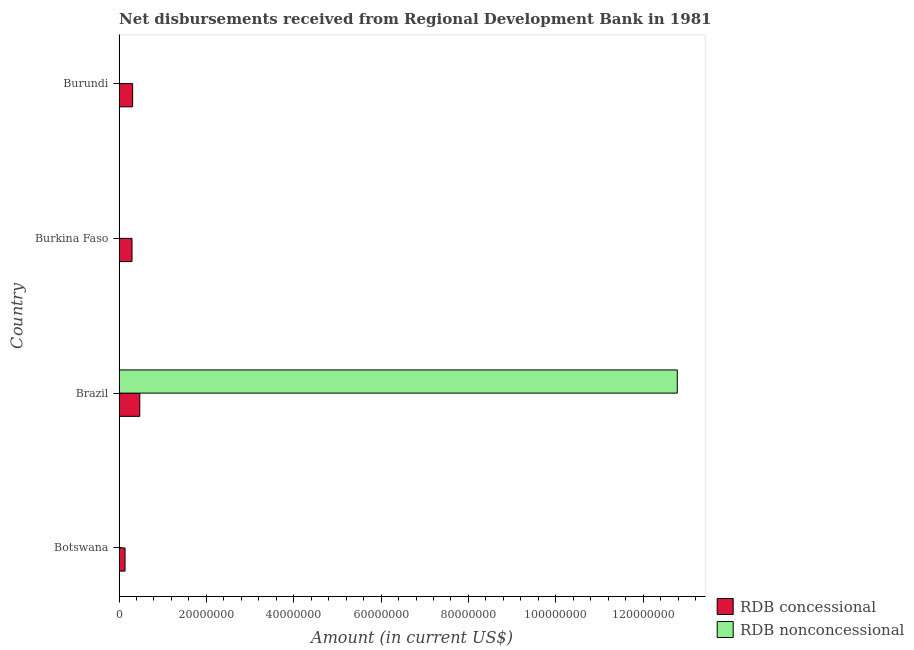How many different coloured bars are there?
Keep it short and to the point. 2. How many bars are there on the 4th tick from the bottom?
Make the answer very short. 1. What is the label of the 3rd group of bars from the top?
Offer a very short reply. Brazil. In how many cases, is the number of bars for a given country not equal to the number of legend labels?
Give a very brief answer. 3. What is the net non concessional disbursements from rdb in Brazil?
Provide a succinct answer. 1.28e+08. Across all countries, what is the maximum net non concessional disbursements from rdb?
Your response must be concise. 1.28e+08. Across all countries, what is the minimum net non concessional disbursements from rdb?
Your answer should be very brief. 0. What is the total net non concessional disbursements from rdb in the graph?
Offer a terse response. 1.28e+08. What is the difference between the net concessional disbursements from rdb in Botswana and that in Burundi?
Keep it short and to the point. -1.74e+06. What is the difference between the net concessional disbursements from rdb in Brazil and the net non concessional disbursements from rdb in Burkina Faso?
Offer a terse response. 4.74e+06. What is the average net concessional disbursements from rdb per country?
Provide a short and direct response. 3.05e+06. What is the difference between the net non concessional disbursements from rdb and net concessional disbursements from rdb in Brazil?
Provide a short and direct response. 1.23e+08. What is the ratio of the net concessional disbursements from rdb in Botswana to that in Burundi?
Your response must be concise. 0.44. What is the difference between the highest and the second highest net concessional disbursements from rdb?
Make the answer very short. 1.63e+06. What is the difference between the highest and the lowest net concessional disbursements from rdb?
Your response must be concise. 3.37e+06. In how many countries, is the net non concessional disbursements from rdb greater than the average net non concessional disbursements from rdb taken over all countries?
Your answer should be very brief. 1. Is the sum of the net concessional disbursements from rdb in Burkina Faso and Burundi greater than the maximum net non concessional disbursements from rdb across all countries?
Provide a succinct answer. No. Are all the bars in the graph horizontal?
Keep it short and to the point. Yes. How many countries are there in the graph?
Your answer should be compact. 4. Where does the legend appear in the graph?
Ensure brevity in your answer.  Bottom right. How many legend labels are there?
Give a very brief answer. 2. What is the title of the graph?
Your answer should be very brief. Net disbursements received from Regional Development Bank in 1981. Does "National Visitors" appear as one of the legend labels in the graph?
Provide a short and direct response. No. What is the label or title of the X-axis?
Provide a succinct answer. Amount (in current US$). What is the Amount (in current US$) in RDB concessional in Botswana?
Provide a short and direct response. 1.37e+06. What is the Amount (in current US$) of RDB nonconcessional in Botswana?
Ensure brevity in your answer.  0. What is the Amount (in current US$) in RDB concessional in Brazil?
Your answer should be compact. 4.74e+06. What is the Amount (in current US$) of RDB nonconcessional in Brazil?
Make the answer very short. 1.28e+08. What is the Amount (in current US$) of RDB concessional in Burkina Faso?
Offer a very short reply. 2.97e+06. What is the Amount (in current US$) of RDB nonconcessional in Burkina Faso?
Offer a very short reply. 0. What is the Amount (in current US$) in RDB concessional in Burundi?
Offer a very short reply. 3.11e+06. What is the Amount (in current US$) in RDB nonconcessional in Burundi?
Keep it short and to the point. 0. Across all countries, what is the maximum Amount (in current US$) of RDB concessional?
Your answer should be very brief. 4.74e+06. Across all countries, what is the maximum Amount (in current US$) of RDB nonconcessional?
Your answer should be compact. 1.28e+08. Across all countries, what is the minimum Amount (in current US$) in RDB concessional?
Give a very brief answer. 1.37e+06. Across all countries, what is the minimum Amount (in current US$) in RDB nonconcessional?
Your answer should be compact. 0. What is the total Amount (in current US$) in RDB concessional in the graph?
Provide a succinct answer. 1.22e+07. What is the total Amount (in current US$) in RDB nonconcessional in the graph?
Provide a short and direct response. 1.28e+08. What is the difference between the Amount (in current US$) of RDB concessional in Botswana and that in Brazil?
Ensure brevity in your answer.  -3.37e+06. What is the difference between the Amount (in current US$) in RDB concessional in Botswana and that in Burkina Faso?
Make the answer very short. -1.60e+06. What is the difference between the Amount (in current US$) in RDB concessional in Botswana and that in Burundi?
Your answer should be very brief. -1.74e+06. What is the difference between the Amount (in current US$) of RDB concessional in Brazil and that in Burkina Faso?
Offer a very short reply. 1.78e+06. What is the difference between the Amount (in current US$) of RDB concessional in Brazil and that in Burundi?
Provide a short and direct response. 1.63e+06. What is the difference between the Amount (in current US$) of RDB concessional in Burkina Faso and that in Burundi?
Keep it short and to the point. -1.45e+05. What is the difference between the Amount (in current US$) in RDB concessional in Botswana and the Amount (in current US$) in RDB nonconcessional in Brazil?
Your answer should be compact. -1.26e+08. What is the average Amount (in current US$) in RDB concessional per country?
Your answer should be very brief. 3.05e+06. What is the average Amount (in current US$) of RDB nonconcessional per country?
Offer a very short reply. 3.20e+07. What is the difference between the Amount (in current US$) in RDB concessional and Amount (in current US$) in RDB nonconcessional in Brazil?
Provide a succinct answer. -1.23e+08. What is the ratio of the Amount (in current US$) in RDB concessional in Botswana to that in Brazil?
Your answer should be compact. 0.29. What is the ratio of the Amount (in current US$) of RDB concessional in Botswana to that in Burkina Faso?
Your response must be concise. 0.46. What is the ratio of the Amount (in current US$) in RDB concessional in Botswana to that in Burundi?
Give a very brief answer. 0.44. What is the ratio of the Amount (in current US$) of RDB concessional in Brazil to that in Burkina Faso?
Provide a succinct answer. 1.6. What is the ratio of the Amount (in current US$) in RDB concessional in Brazil to that in Burundi?
Ensure brevity in your answer.  1.52. What is the ratio of the Amount (in current US$) in RDB concessional in Burkina Faso to that in Burundi?
Provide a short and direct response. 0.95. What is the difference between the highest and the second highest Amount (in current US$) of RDB concessional?
Provide a short and direct response. 1.63e+06. What is the difference between the highest and the lowest Amount (in current US$) of RDB concessional?
Provide a short and direct response. 3.37e+06. What is the difference between the highest and the lowest Amount (in current US$) of RDB nonconcessional?
Offer a terse response. 1.28e+08. 